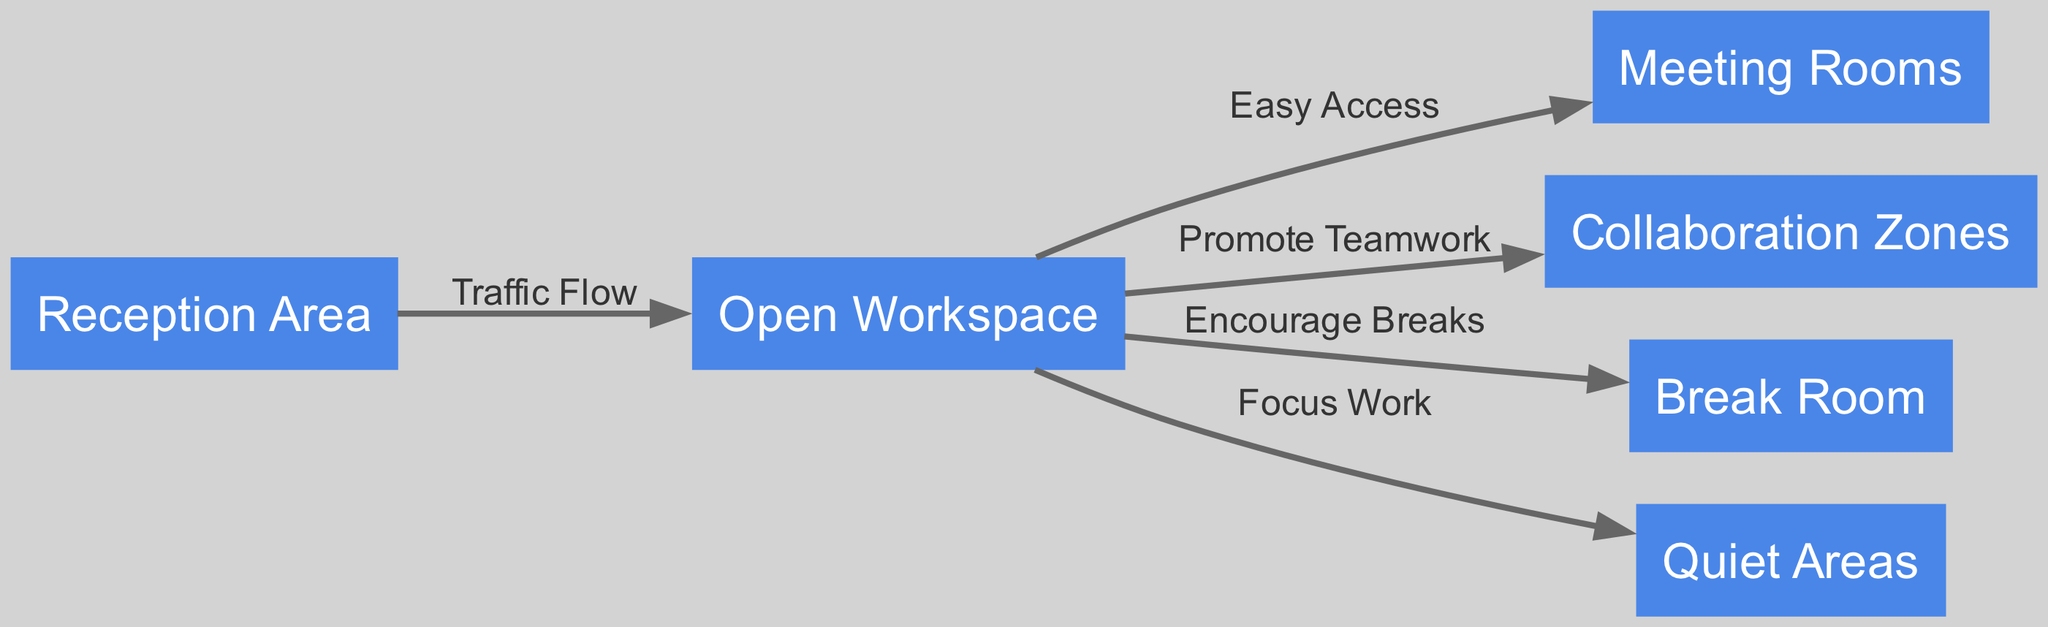What is the total number of nodes in the diagram? The diagram includes six distinct nodes: Reception Area, Open Workspace, Meeting Rooms, Collaboration Zones, Break Room, and Quiet Areas. Counting these gives a total of six nodes.
Answer: 6 What is the primary function of the Open Workspace? The Open Workspace connects to multiple other nodes, such as Meeting Rooms, Collaboration Zones, Break Room, and Quiet Areas, indicating its role as a central area that facilitates access and interaction, supporting teamwork and encouraging breaks.
Answer: Facilitate access What edge connects the Open Workspace to the Meeting Rooms? The edge that connects these two nodes is labeled "Easy Access," indicating that the flow between the Open Workspace and Meeting Rooms is intended to be straightforward and efficient.
Answer: Easy Access How many edges originate from the Open Workspace? The Open Workspace has five outgoing edges, connecting to Meeting Rooms, Collaboration Zones, Break Room, Quiet Areas, and the Reception Area. This shows that it serves as a hub connecting various important areas in the office layout.
Answer: 5 Which node is connected to the Reception Area? The Reception Area is connected to the Open Workspace with the edge labeled "Traffic Flow," which implies that movement from the reception area leads directly into the Open Workspace.
Answer: Open Workspace What is the relationship between the Open Workspace and Collaboration Zones? The labeled edge between these two nodes is "Promote Teamwork," indicating that the design of the office layout encourages collaboration among team members located in the Open Workspace and Collaboration Zones.
Answer: Promote Teamwork What area is designed specifically for relaxing breaks? The Break Room node was explicitly designed to serve as a space for employees to take breaks and recharge, distinct from areas meant for focused work or collaboration.
Answer: Break Room How does the design promote focus work? The edge labeled "Focus Work" connects the Open Workspace to the Quiet Areas, suggesting that the layout allows for transition from active spaces to quieter, more focused work environments.
Answer: Quiet Areas 